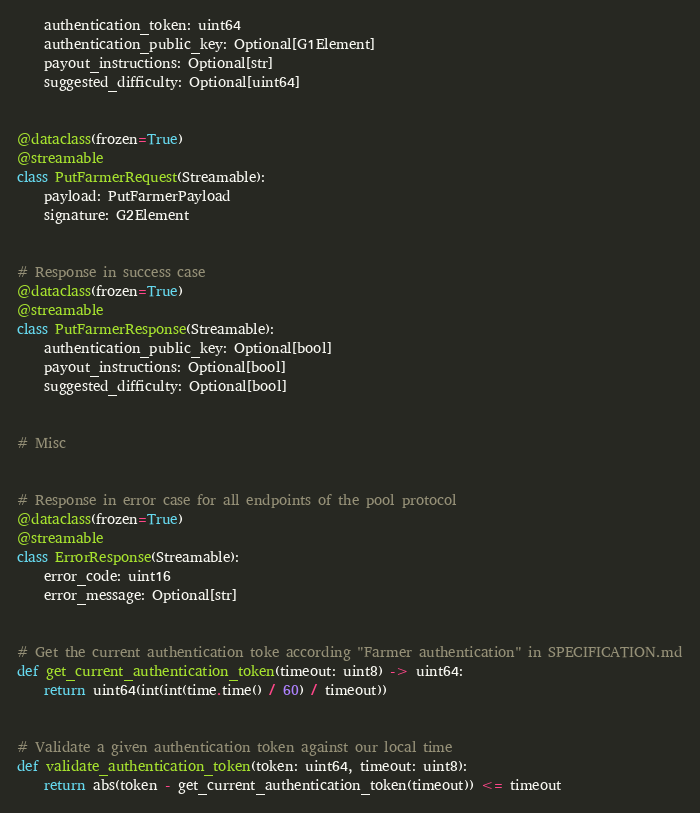Convert code to text. <code><loc_0><loc_0><loc_500><loc_500><_Python_>    authentication_token: uint64
    authentication_public_key: Optional[G1Element]
    payout_instructions: Optional[str]
    suggested_difficulty: Optional[uint64]


@dataclass(frozen=True)
@streamable
class PutFarmerRequest(Streamable):
    payload: PutFarmerPayload
    signature: G2Element


# Response in success case
@dataclass(frozen=True)
@streamable
class PutFarmerResponse(Streamable):
    authentication_public_key: Optional[bool]
    payout_instructions: Optional[bool]
    suggested_difficulty: Optional[bool]


# Misc


# Response in error case for all endpoints of the pool protocol
@dataclass(frozen=True)
@streamable
class ErrorResponse(Streamable):
    error_code: uint16
    error_message: Optional[str]


# Get the current authentication toke according "Farmer authentication" in SPECIFICATION.md
def get_current_authentication_token(timeout: uint8) -> uint64:
    return uint64(int(int(time.time() / 60) / timeout))


# Validate a given authentication token against our local time
def validate_authentication_token(token: uint64, timeout: uint8):
    return abs(token - get_current_authentication_token(timeout)) <= timeout
</code> 